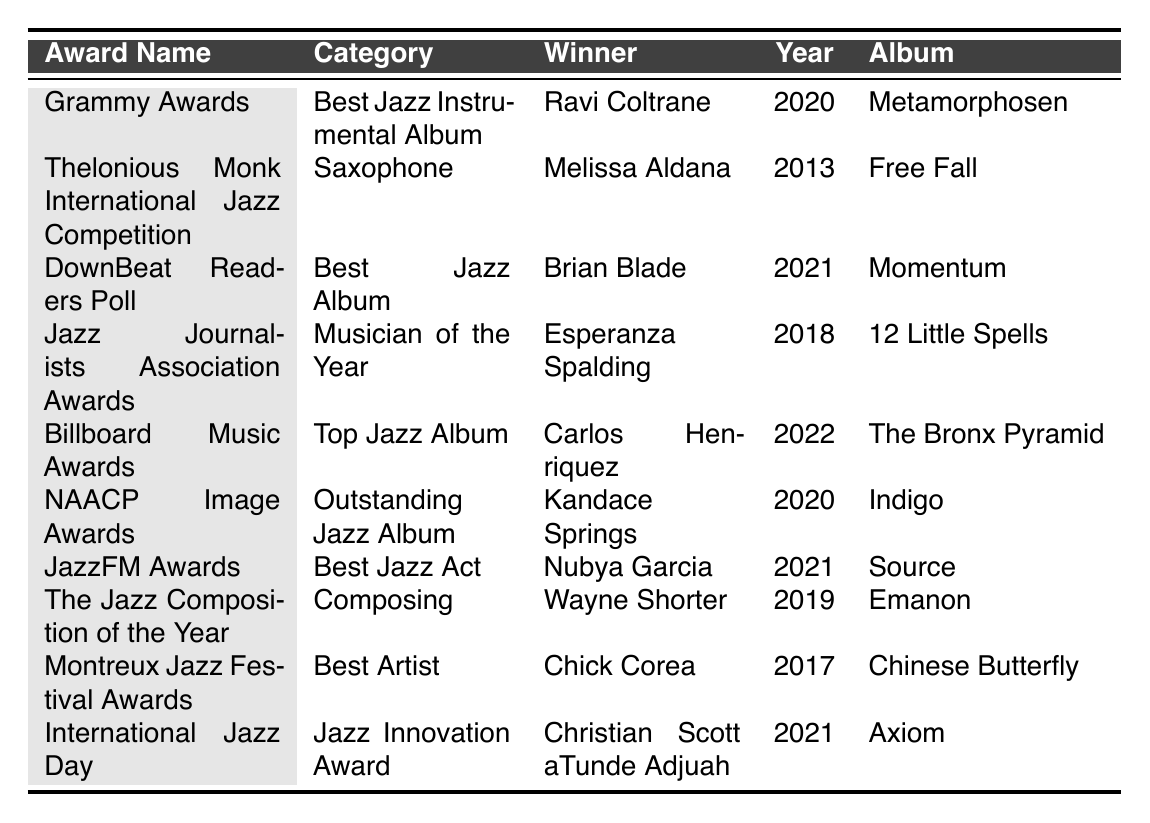What is the winner of the Grammy Awards in 2020? The table lists the winner of the Grammy Awards in 2020 as Ravi Coltrane for the album "Metamorphosen."
Answer: Ravi Coltrane Which musician won the Thelonious Monk International Jazz Competition in 2013? According to the table, Melissa Aldana won the Thelonious Monk International Jazz Competition in 2013 for her album "Free Fall."
Answer: Melissa Aldana How many awards did Esperanza Spalding receive as per the table? The table shows that Esperanza Spalding won the Jazz Journalists Association Awards for Musician of the Year in 2018. Thus, she received one award as per this data.
Answer: One award What is the album associated with the winner of the Billboard Music Awards in 2022? The table states that Carlos Henriquez won the Billboard Music Awards for the Top Jazz Album in 2022, and his associated album is "The Bronx Pyramid."
Answer: The Bronx Pyramid Identify the two winners for the year 2021 from the table. The table lists two winners for 2021: Brian Blade for the DownBeat Readers Poll (Best Jazz Album) and Nubya Garcia for the JazzFM Awards (Best Jazz Act).
Answer: Brian Blade and Nubya Garcia Which award was given for the album "Indigo"? The NAACP Image Awards presented the Outstanding Jazz Album award for the album "Indigo" in 2020, won by Kandace Springs.
Answer: NAACP Image Awards Was Chick Corea awarded in a year before 2018? The table shows that Chick Corea won the Montreux Jazz Festival Awards for Best Artist in 2017, which is indeed before 2018.
Answer: Yes How many winners are listed for the category “Best Jazz Act”? The table indicates that Nubya Garcia is the only winner listed for the category “Best Jazz Act,” which she received in 2021.
Answer: One winner In which year did Wayne Shorter win the award for The Jazz Composition of the Year? According to the table, Wayne Shorter won the award for The Jazz Composition of the Year in 2019 for his album "Emanon."
Answer: 2019 What is the relationship between the award “Saxophone” and its winner? The table shows that the award “Saxophone” is part of the Thelonious Monk International Jazz Competition, and its winner is Melissa Aldana, who received this award in 2013 for her album "Free Fall."
Answer: Melissa Aldana won the Saxophone award 